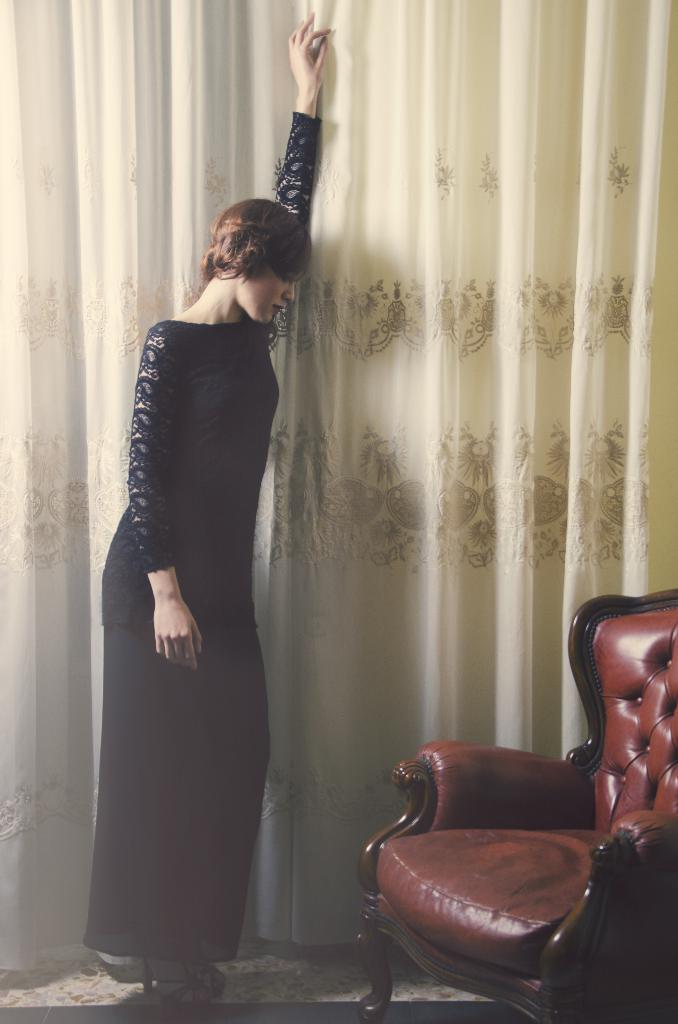Who is the main subject in the image? There is a lady in the image. What is the lady wearing? The lady is wearing a black dress. How would you describe the lady's appearance? The lady is stunning. What can be seen in front of the lady? There is a red color chair in front of the lady. What is visible in the background of the image? There is a curtain in the background of the image. What type of health advice can be seen in the image? There is no health advice present in the image; it features a lady in a black dress with a red chair and a curtain in the background. Can you tell me how many experts are present in the image? There are no experts present in the image; it features a lady in a black dress with a red chair and a curtain in the background. 